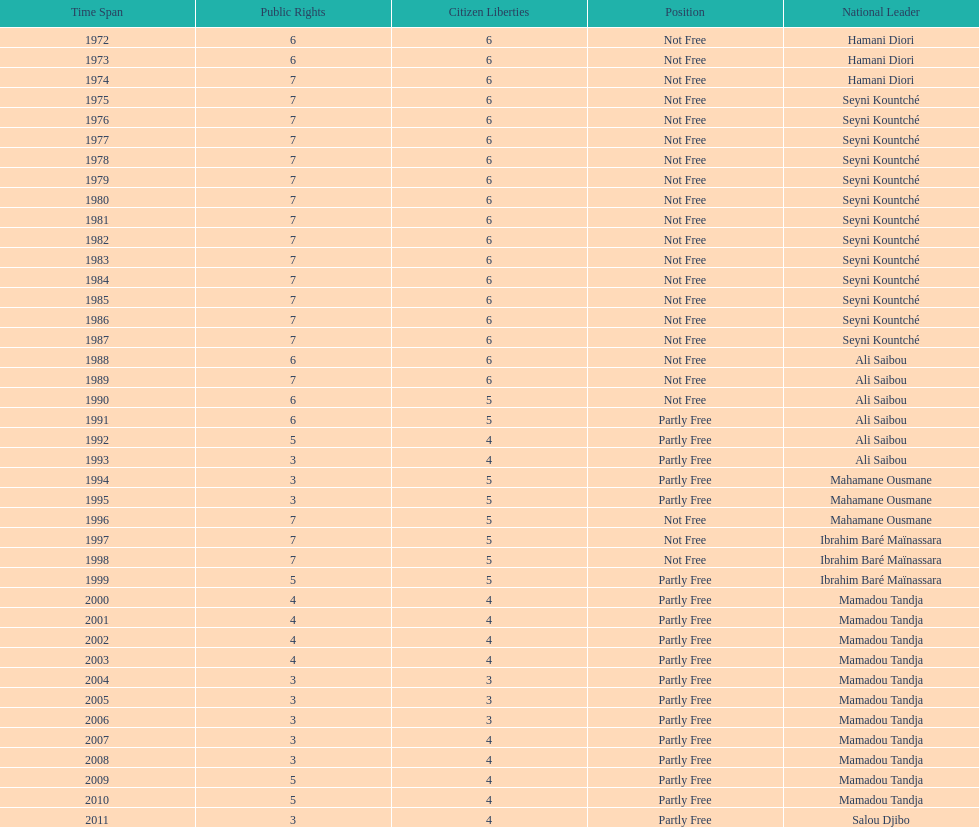Who became president after hamani diori in 1974? Seyni Kountché. 